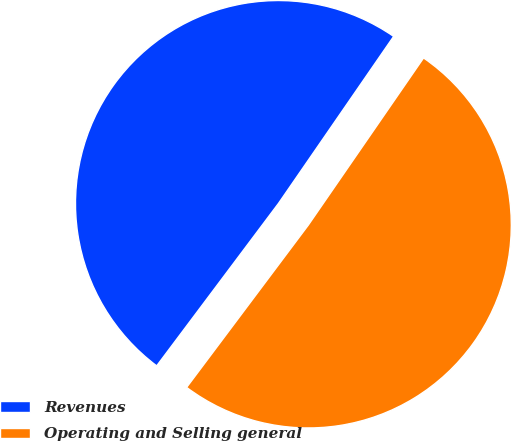Convert chart. <chart><loc_0><loc_0><loc_500><loc_500><pie_chart><fcel>Revenues<fcel>Operating and Selling general<nl><fcel>49.37%<fcel>50.63%<nl></chart> 